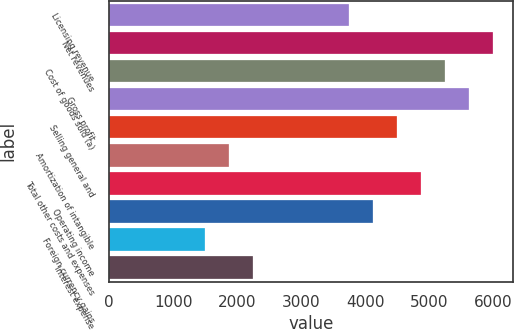<chart> <loc_0><loc_0><loc_500><loc_500><bar_chart><fcel>Licensing revenue<fcel>Net revenues<fcel>Cost of goods sold (a)<fcel>Gross profit<fcel>Selling general and<fcel>Amortization of intangible<fcel>Total other costs and expenses<fcel>Operating income<fcel>Foreign currency gains<fcel>Interest expense<nl><fcel>3746.3<fcel>5993.96<fcel>5244.74<fcel>5619.35<fcel>4495.52<fcel>1873.25<fcel>4870.13<fcel>4120.91<fcel>1498.64<fcel>2247.86<nl></chart> 